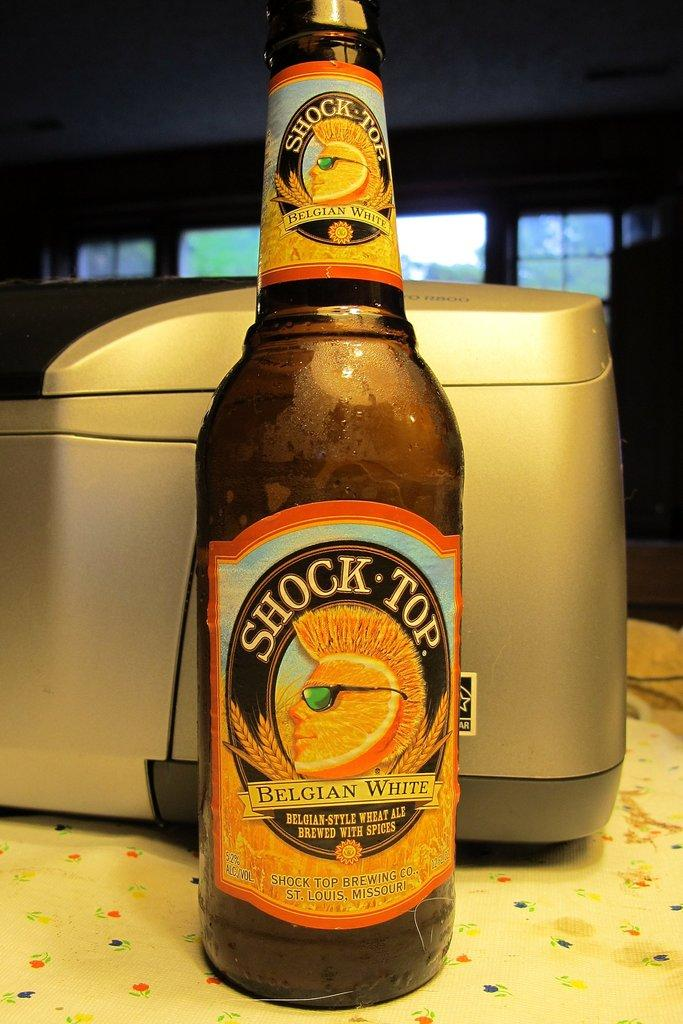Provide a one-sentence caption for the provided image. Twelve fluid ounce bottle of Shock Top Belgian white Ale. 